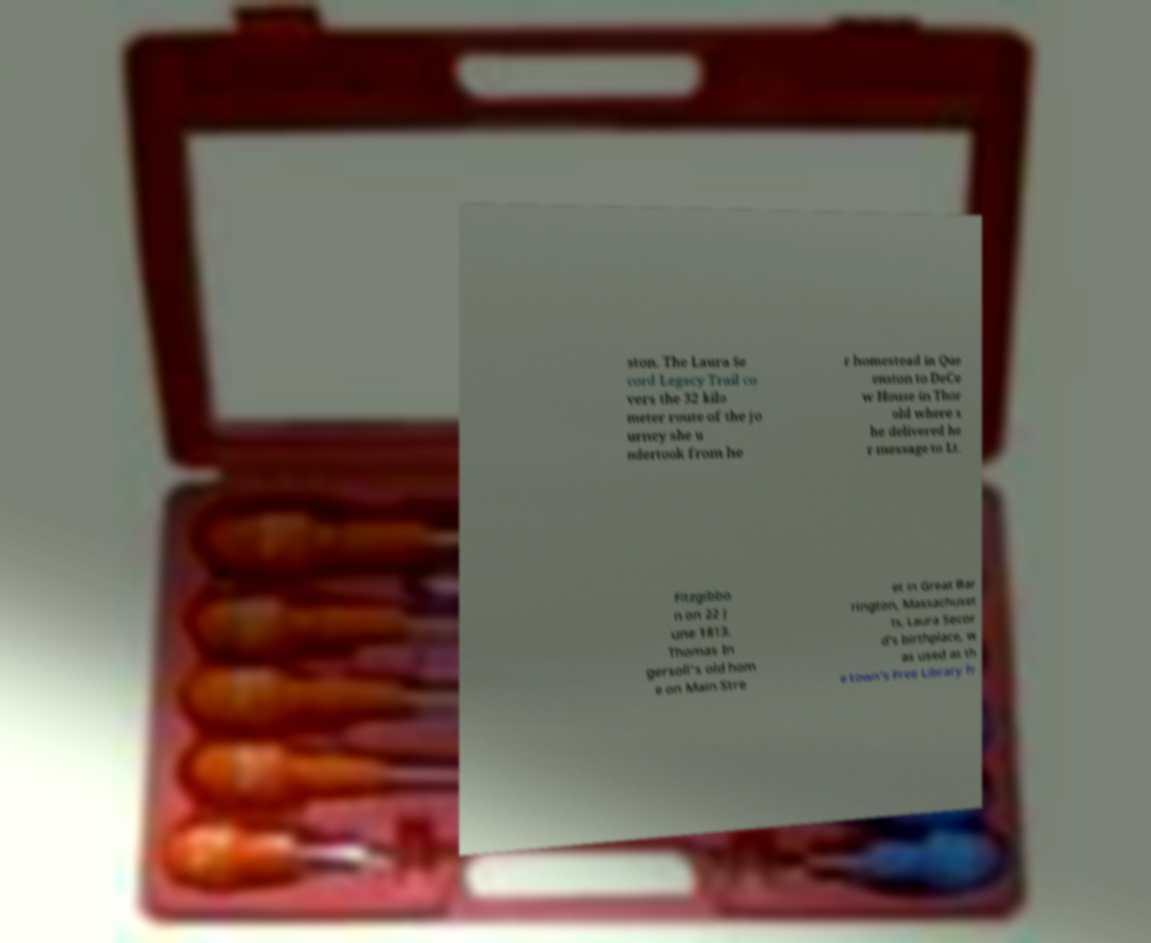Please identify and transcribe the text found in this image. ston. The Laura Se cord Legacy Trail co vers the 32 kilo meter route of the jo urney she u ndertook from he r homestead in Que enston to DeCe w House in Thor old where s he delivered he r message to Lt. Fitzgibbo n on 22 J une 1813. Thomas In gersoll's old hom e on Main Stre et in Great Bar rington, Massachuset ts, Laura Secor d's birthplace, w as used as th e town's Free Library fr 